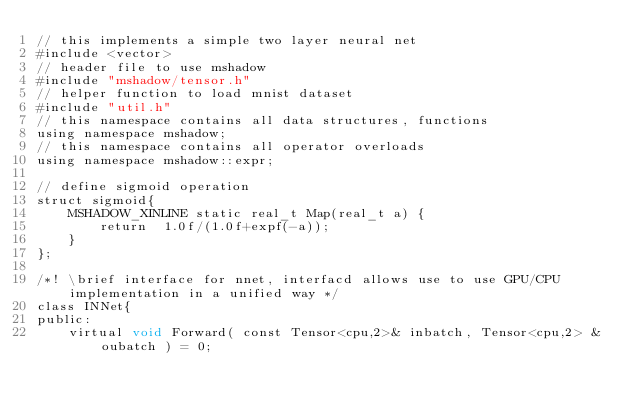Convert code to text. <code><loc_0><loc_0><loc_500><loc_500><_Cuda_>// this implements a simple two layer neural net
#include <vector>
// header file to use mshadow
#include "mshadow/tensor.h"
// helper function to load mnist dataset
#include "util.h"
// this namespace contains all data structures, functions
using namespace mshadow;
// this namespace contains all operator overloads
using namespace mshadow::expr;

// define sigmoid operation
struct sigmoid{
    MSHADOW_XINLINE static real_t Map(real_t a) {
        return  1.0f/(1.0f+expf(-a));
    }
};

/*! \brief interface for nnet, interfacd allows use to use GPU/CPU implementation in a unified way */
class INNet{
public:
    virtual void Forward( const Tensor<cpu,2>& inbatch, Tensor<cpu,2> &oubatch ) = 0;</code> 